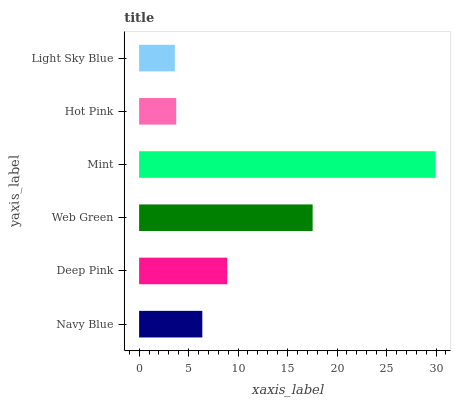Is Light Sky Blue the minimum?
Answer yes or no. Yes. Is Mint the maximum?
Answer yes or no. Yes. Is Deep Pink the minimum?
Answer yes or no. No. Is Deep Pink the maximum?
Answer yes or no. No. Is Deep Pink greater than Navy Blue?
Answer yes or no. Yes. Is Navy Blue less than Deep Pink?
Answer yes or no. Yes. Is Navy Blue greater than Deep Pink?
Answer yes or no. No. Is Deep Pink less than Navy Blue?
Answer yes or no. No. Is Deep Pink the high median?
Answer yes or no. Yes. Is Navy Blue the low median?
Answer yes or no. Yes. Is Web Green the high median?
Answer yes or no. No. Is Light Sky Blue the low median?
Answer yes or no. No. 